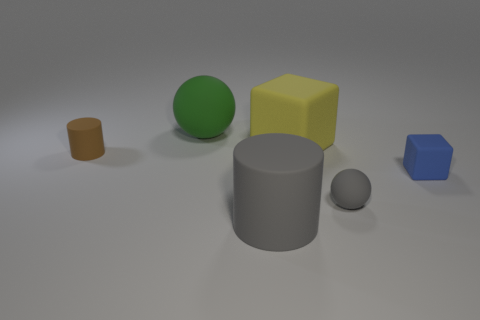Add 4 brown matte cylinders. How many objects exist? 10 Subtract all balls. How many objects are left? 4 Subtract all brown cylinders. How many cylinders are left? 1 Subtract 0 purple cylinders. How many objects are left? 6 Subtract 2 spheres. How many spheres are left? 0 Subtract all purple spheres. Subtract all blue cylinders. How many spheres are left? 2 Subtract all tiny blocks. Subtract all big gray cylinders. How many objects are left? 4 Add 1 gray balls. How many gray balls are left? 2 Add 1 metallic blocks. How many metallic blocks exist? 1 